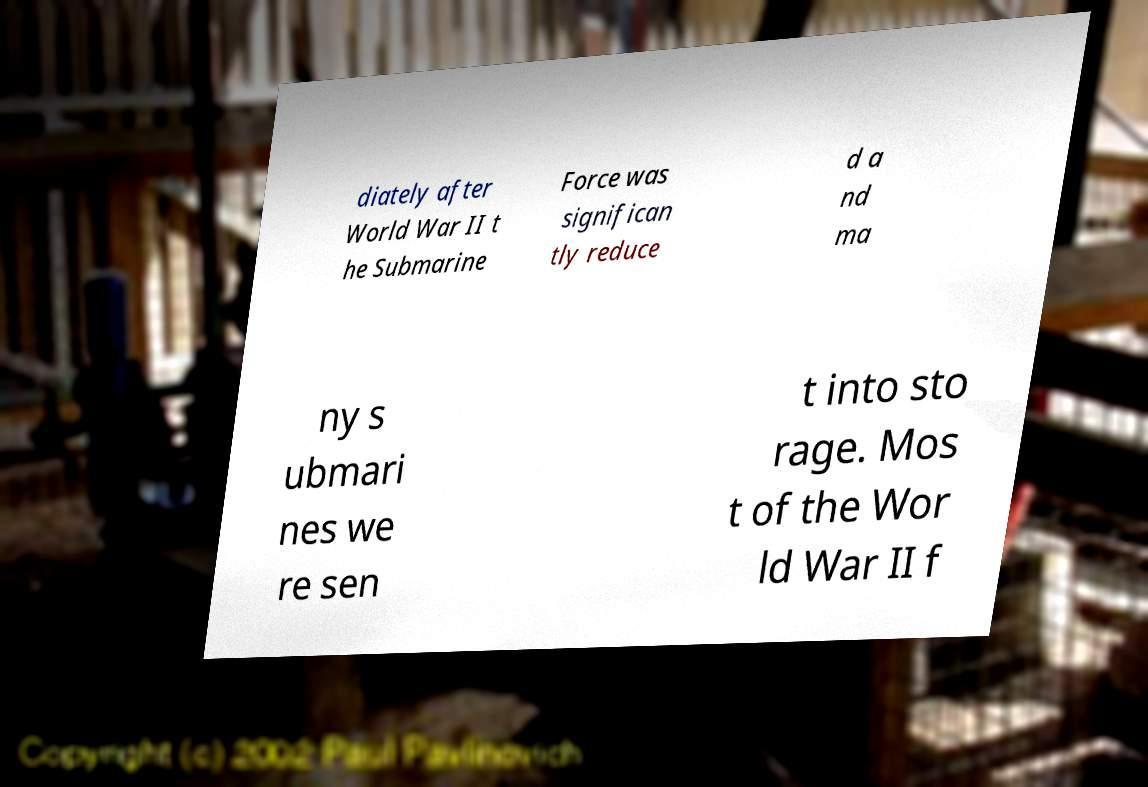Can you read and provide the text displayed in the image?This photo seems to have some interesting text. Can you extract and type it out for me? diately after World War II t he Submarine Force was significan tly reduce d a nd ma ny s ubmari nes we re sen t into sto rage. Mos t of the Wor ld War II f 